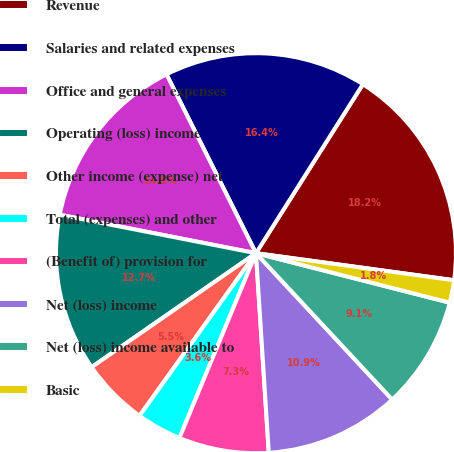Convert chart to OTSL. <chart><loc_0><loc_0><loc_500><loc_500><pie_chart><fcel>Revenue<fcel>Salaries and related expenses<fcel>Office and general expenses<fcel>Operating (loss) income<fcel>Other income (expense) net<fcel>Total (expenses) and other<fcel>(Benefit of) provision for<fcel>Net (loss) income<fcel>Net (loss) income available to<fcel>Basic<nl><fcel>18.18%<fcel>16.36%<fcel>14.54%<fcel>12.73%<fcel>5.46%<fcel>3.64%<fcel>7.27%<fcel>10.91%<fcel>9.09%<fcel>1.82%<nl></chart> 